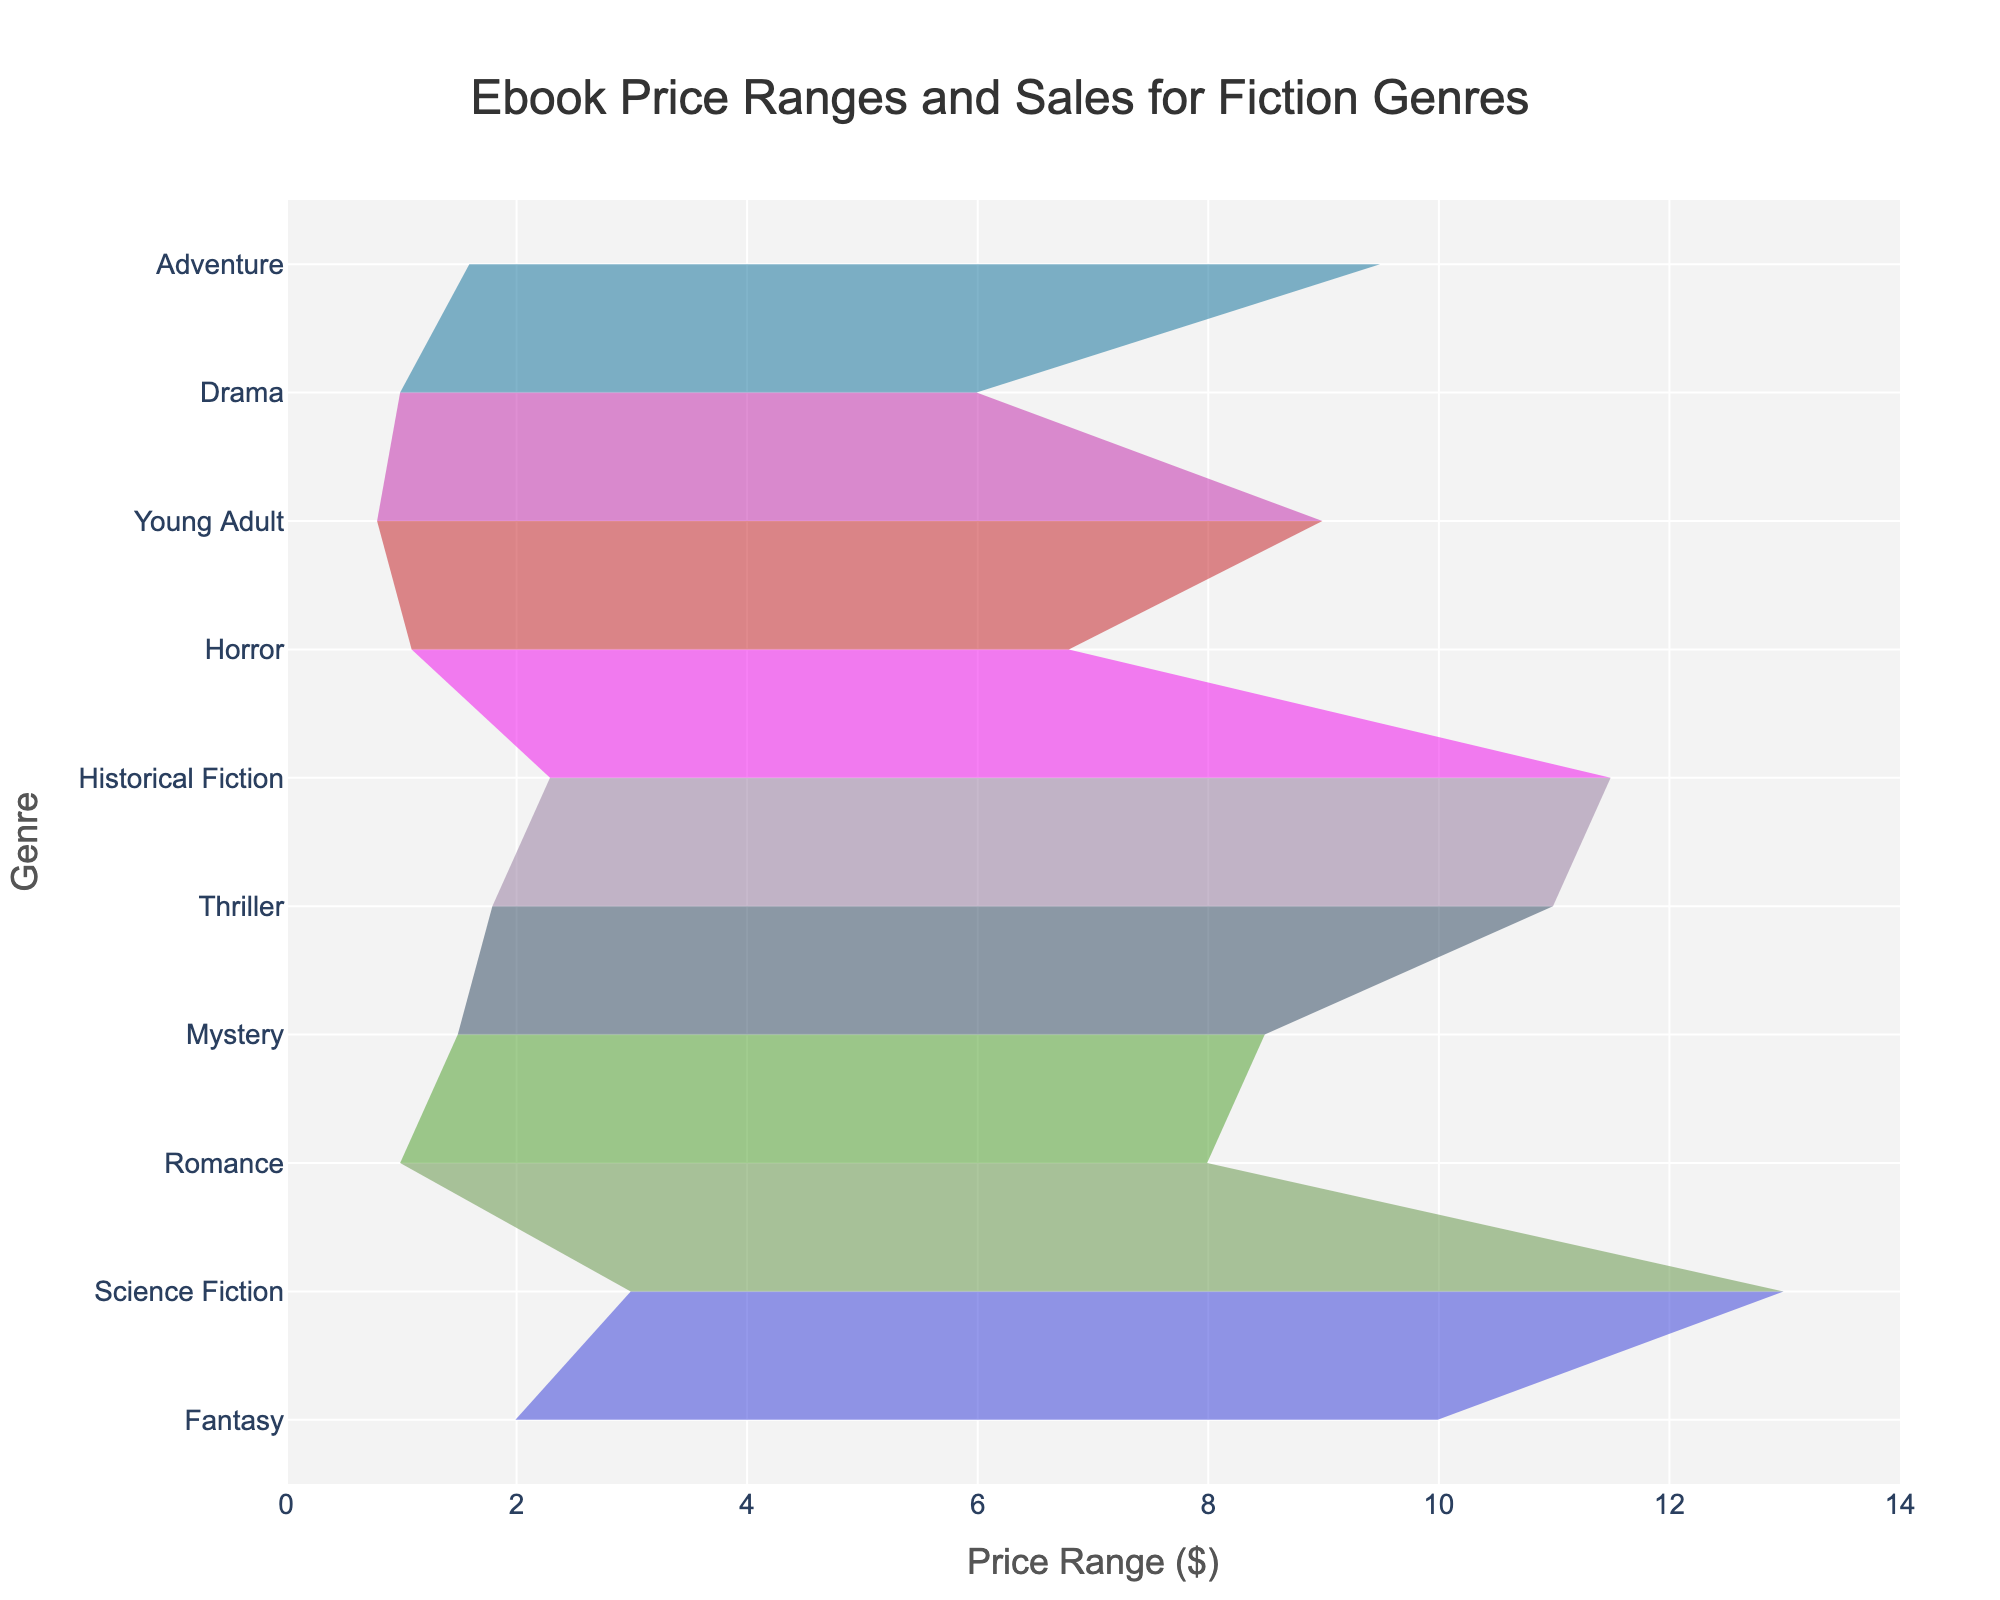What's the title of the chart? The title is prominently displayed at the top of the chart. It indicates what the data represents.
Answer: Ebook Price Ranges and Sales for Fiction Genres What is the price range for Science Fiction? By locating the Science Fiction row and checking the axis for Price Range, the minimum price is $2.99, and the maximum price is $12.99.
Answer: $2.99 to $12.99 Which genre has the highest maximum sales? Reviewing the maximum sales values for each genre, Romance has the highest maximum sales with 5000 sales.
Answer: Romance Which genre has the lowest minimum price? By scanning the Price Min column across all genres, Young Adult has the lowest minimum price of $0.79.
Answer: Young Adult How does the maximum price of Fantasy compare to Thriller? The maximum price of Fantasy is $9.99, while Thriller's maximum price is $10.99. Comparing these, Thriller has a higher maximum price.
Answer: Thriller's maximum price is higher Which genre has the least variation in sales? By calculating the difference between maximum and minimum sales for each genre, Historical Fiction has the smallest variation (1200 sales).
Answer: Historical Fiction What is the average price range for Mystery? The minimum price of Mystery is $1.49, and the maximum price is $8.49. The average price range is calculated as (1.49 + 8.49) / 2 = 4.99.
Answer: $4.99 What is the price range span for Dragon compared to Science Fiction? The price range span of Fantasy ($9.99 - $1.99 = $8) is compared with Science Fiction ($12.99 - $2.99 = $10). Science Fiction has a greater price range span.
Answer: Science Fiction has a greater span Which genre has the maximum price below $8 and what are its sales ranges? Drama and Horror both have maximum prices below $8. Drama's sales range is 700 to 2000, and Horror's sales range is 200 to 1300.
Answer: Drama (700-2000), Horror (200-1300) 